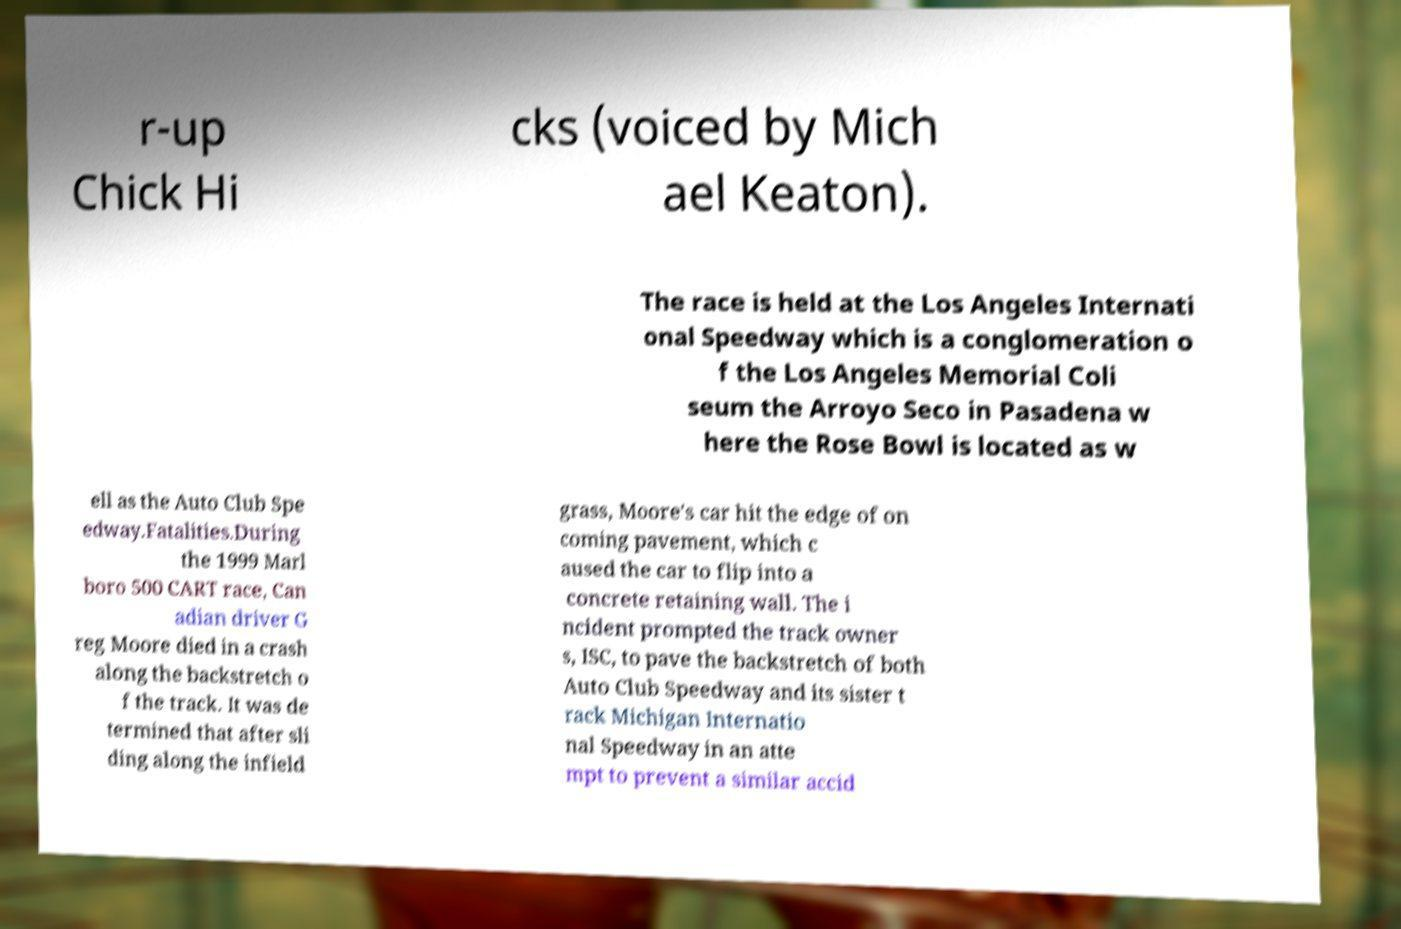Could you assist in decoding the text presented in this image and type it out clearly? r-up Chick Hi cks (voiced by Mich ael Keaton). The race is held at the Los Angeles Internati onal Speedway which is a conglomeration o f the Los Angeles Memorial Coli seum the Arroyo Seco in Pasadena w here the Rose Bowl is located as w ell as the Auto Club Spe edway.Fatalities.During the 1999 Marl boro 500 CART race, Can adian driver G reg Moore died in a crash along the backstretch o f the track. It was de termined that after sli ding along the infield grass, Moore's car hit the edge of on coming pavement, which c aused the car to flip into a concrete retaining wall. The i ncident prompted the track owner s, ISC, to pave the backstretch of both Auto Club Speedway and its sister t rack Michigan Internatio nal Speedway in an atte mpt to prevent a similar accid 